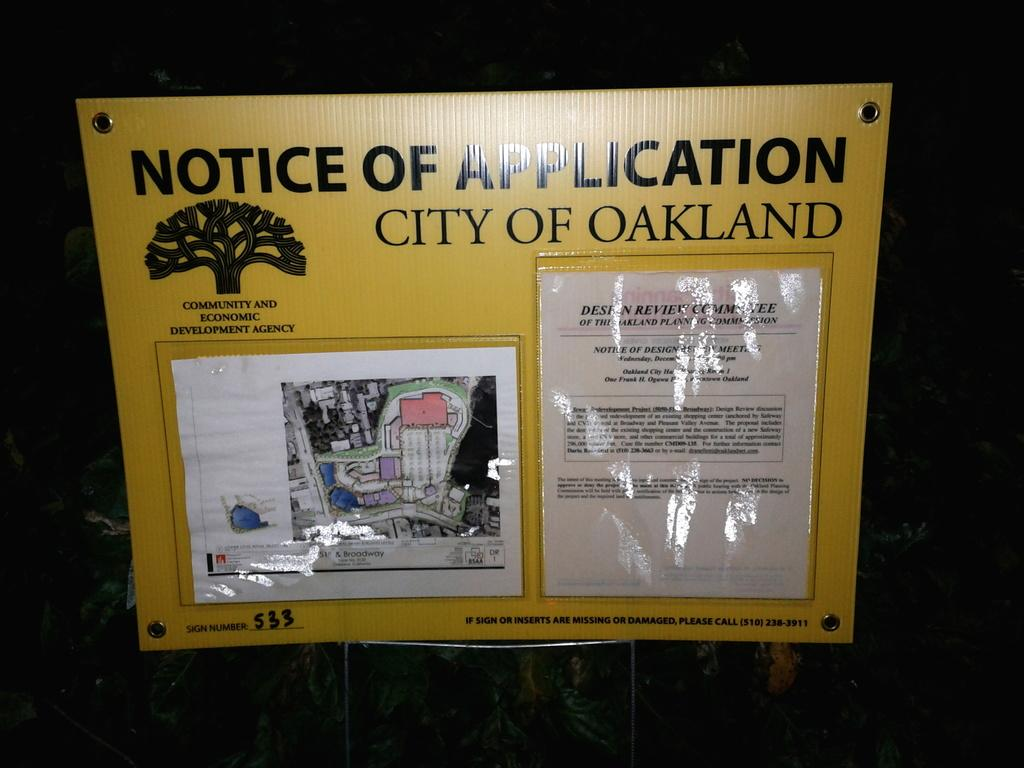<image>
Relay a brief, clear account of the picture shown. A notice of application for the city of Oakland with a tree logo and a map. 